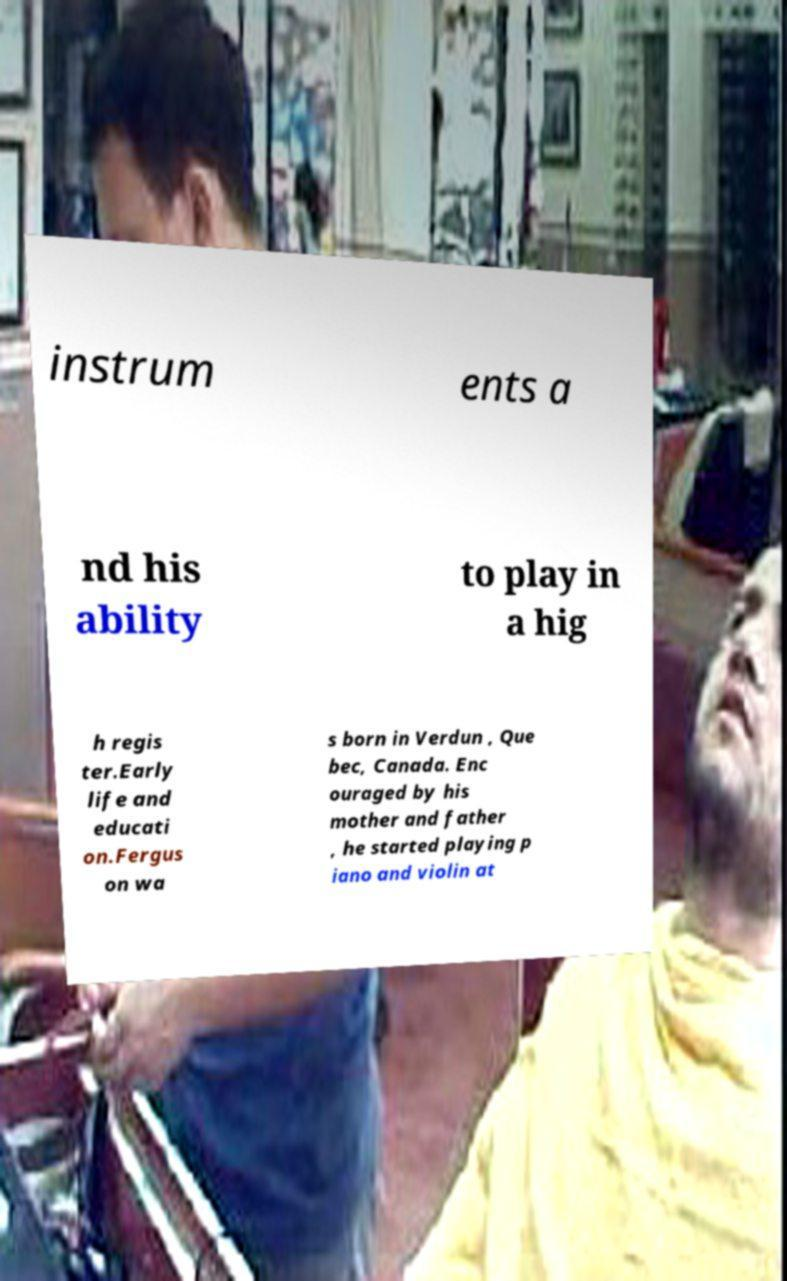Could you assist in decoding the text presented in this image and type it out clearly? instrum ents a nd his ability to play in a hig h regis ter.Early life and educati on.Fergus on wa s born in Verdun , Que bec, Canada. Enc ouraged by his mother and father , he started playing p iano and violin at 